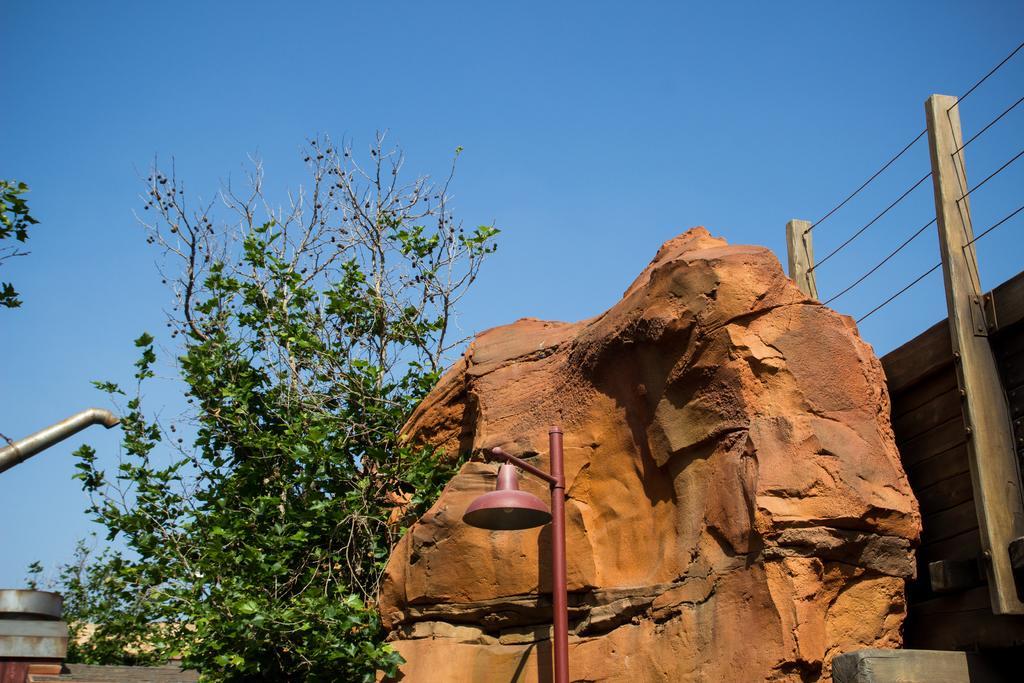Could you give a brief overview of what you see in this image? In this picture I can see a rock, a light pole and few trees in the front. On the left side of this image I can see a rod. On the right side of this image I can see the fencing. In the background I can see the clear sky. 